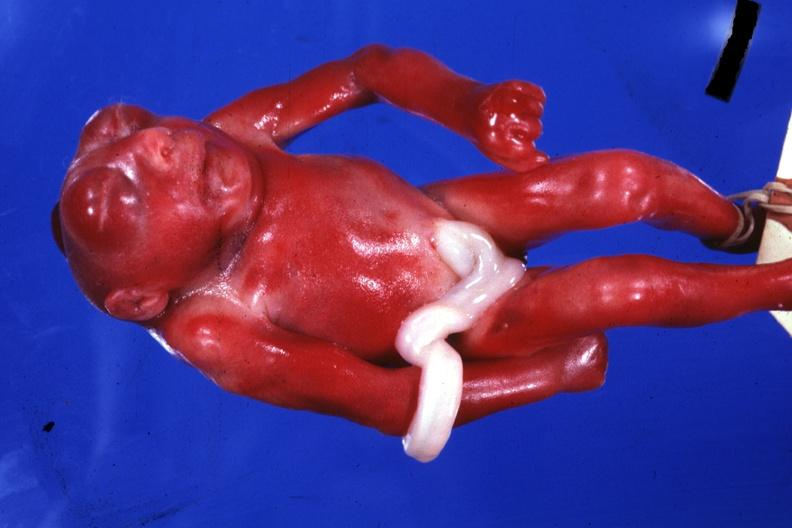s anencephaly present?
Answer the question using a single word or phrase. Yes 